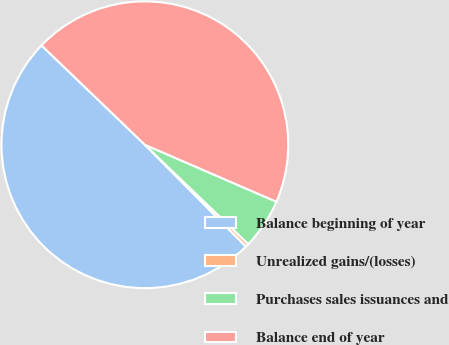<chart> <loc_0><loc_0><loc_500><loc_500><pie_chart><fcel>Balance beginning of year<fcel>Unrealized gains/(losses)<fcel>Purchases sales issuances and<fcel>Balance end of year<nl><fcel>49.62%<fcel>0.38%<fcel>5.68%<fcel>44.32%<nl></chart> 